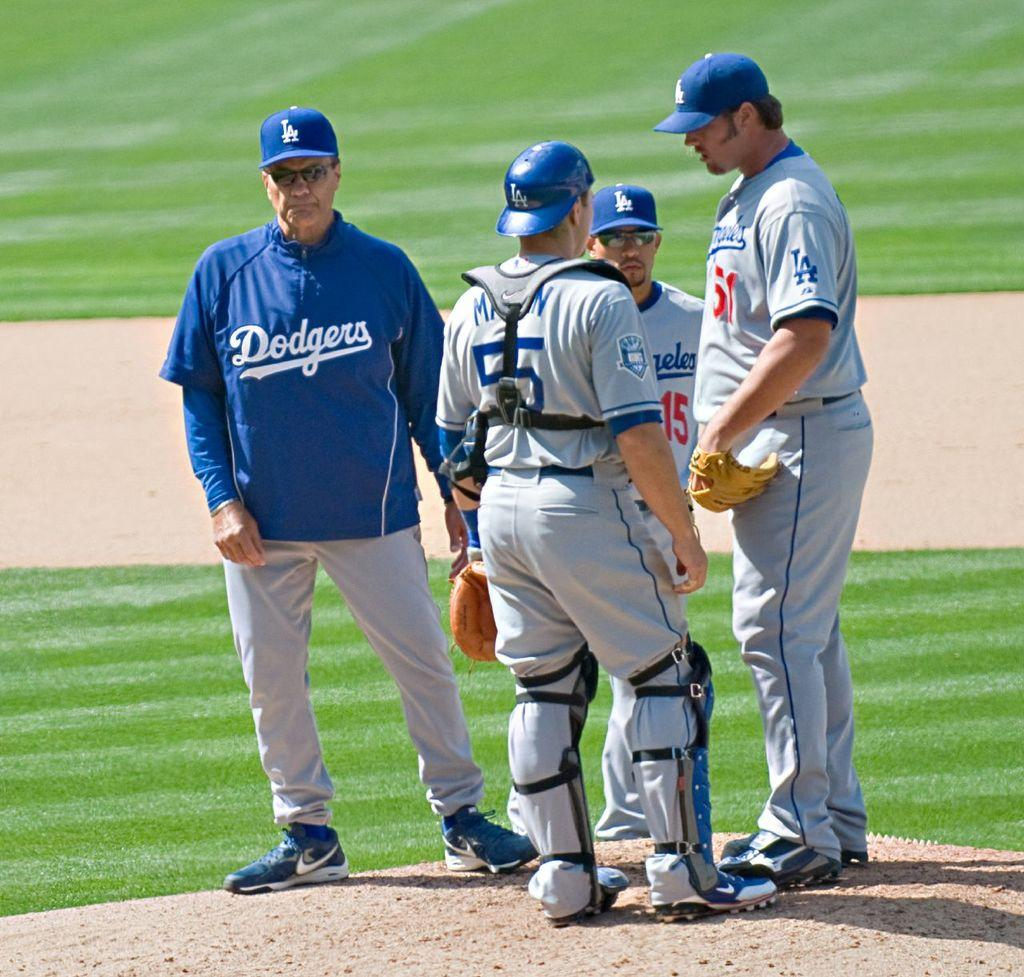<image>
Write a terse but informative summary of the picture. A trio of Dodgers players confer as one of their coaches looks on. 